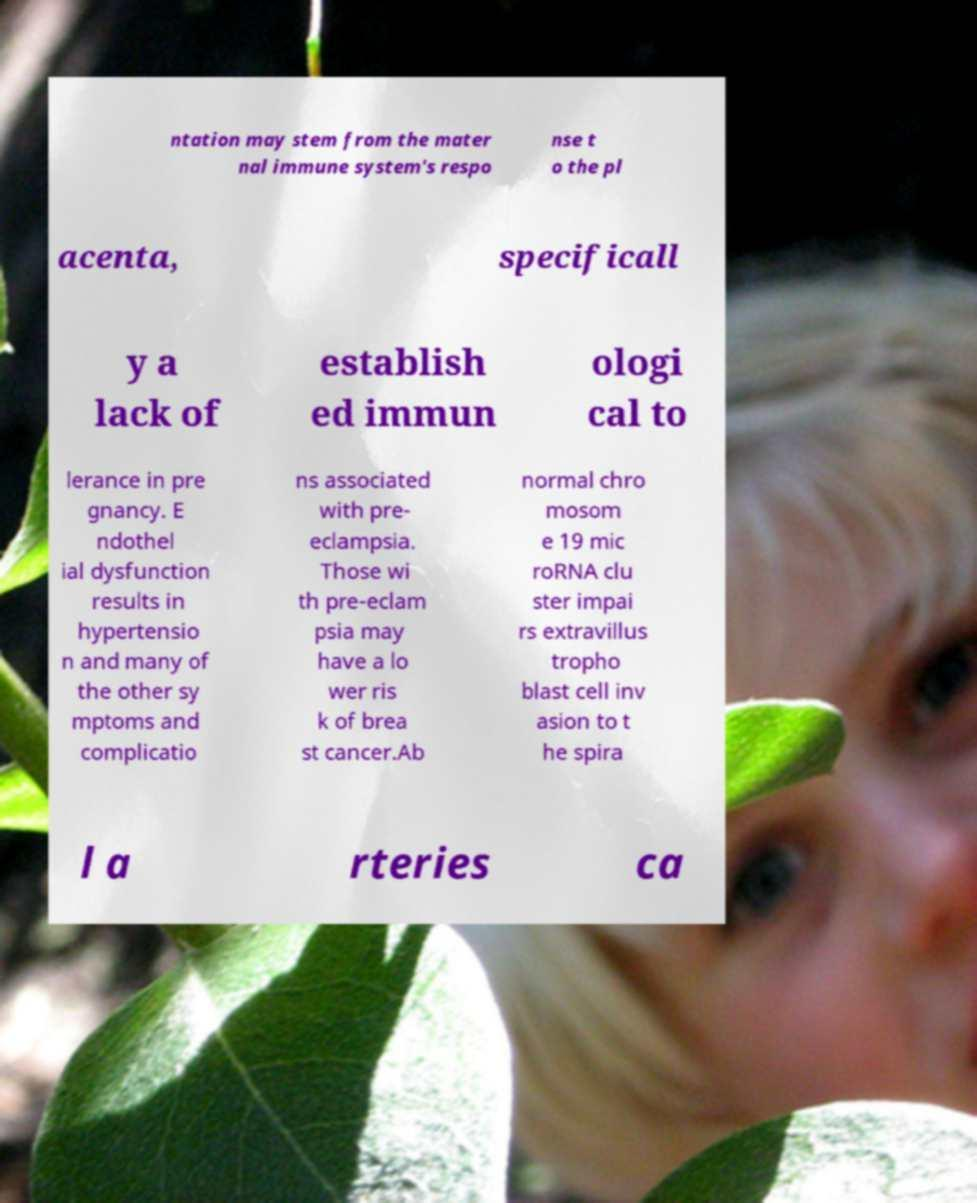Please read and relay the text visible in this image. What does it say? ntation may stem from the mater nal immune system's respo nse t o the pl acenta, specificall y a lack of establish ed immun ologi cal to lerance in pre gnancy. E ndothel ial dysfunction results in hypertensio n and many of the other sy mptoms and complicatio ns associated with pre- eclampsia. Those wi th pre-eclam psia may have a lo wer ris k of brea st cancer.Ab normal chro mosom e 19 mic roRNA clu ster impai rs extravillus tropho blast cell inv asion to t he spira l a rteries ca 